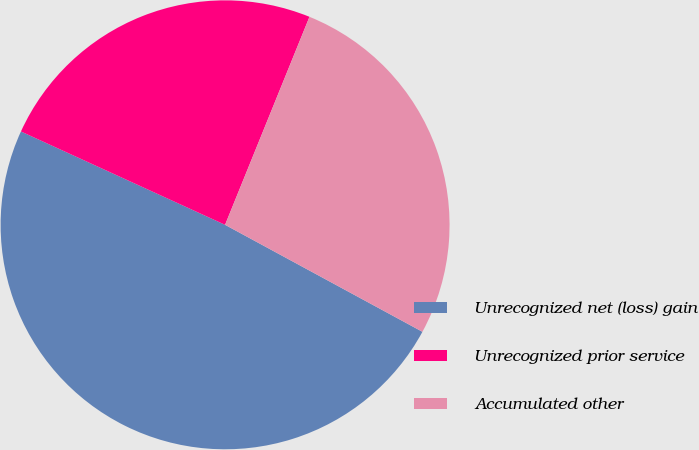Convert chart. <chart><loc_0><loc_0><loc_500><loc_500><pie_chart><fcel>Unrecognized net (loss) gain<fcel>Unrecognized prior service<fcel>Accumulated other<nl><fcel>48.92%<fcel>24.31%<fcel>26.77%<nl></chart> 